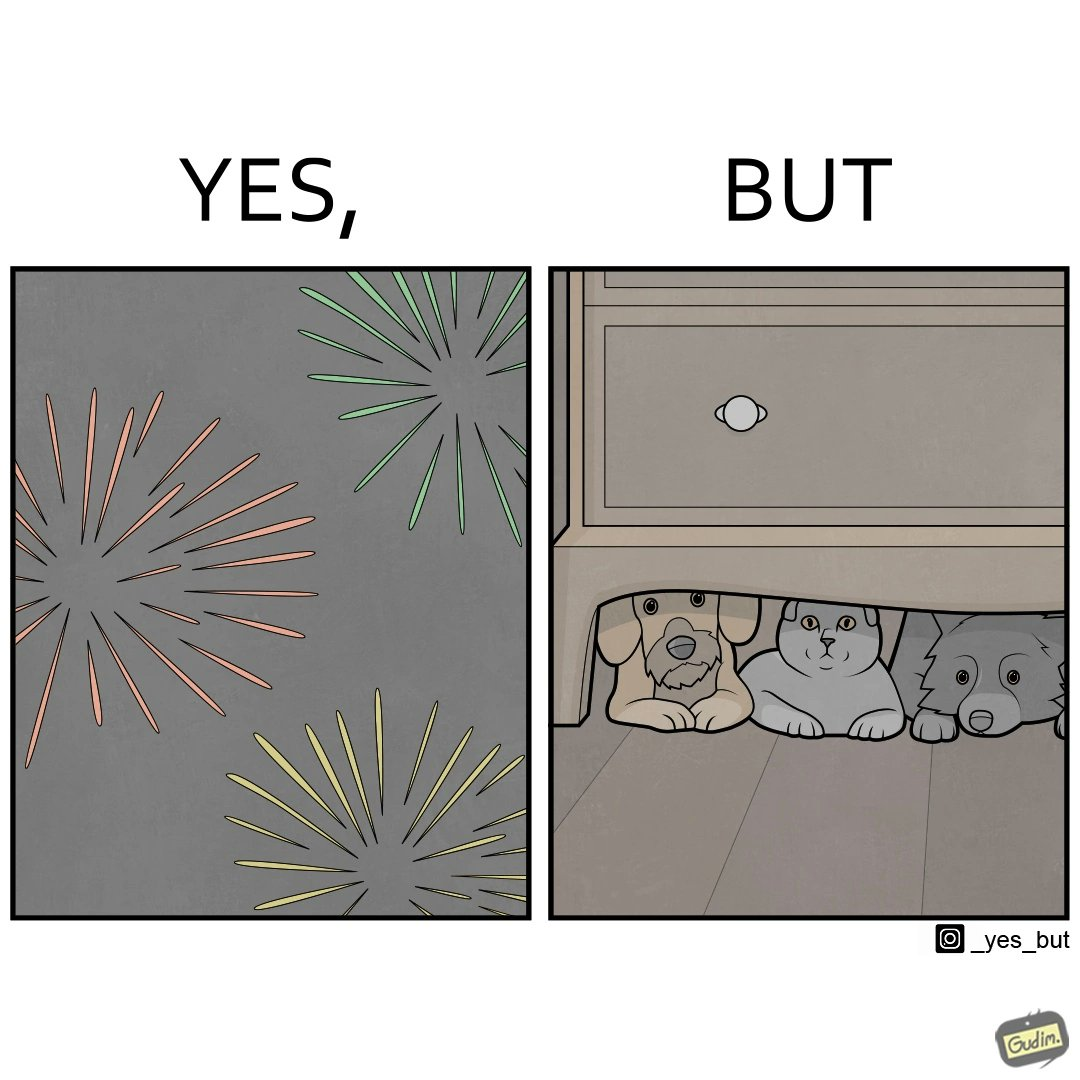What is the satirical meaning behind this image? The image is satirical because while firecrackers in the sky look pretty, not everyone likes them. Animals are very scared of the firecrackers. 